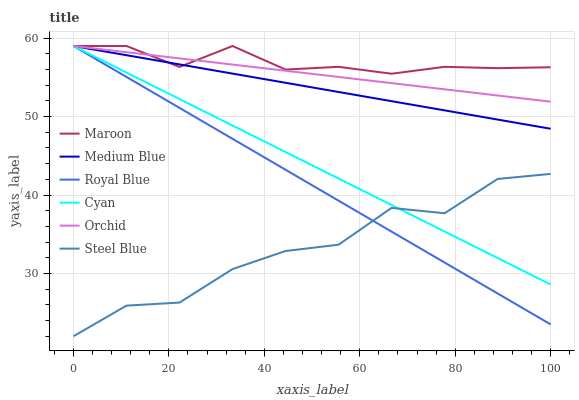Does Steel Blue have the minimum area under the curve?
Answer yes or no. Yes. Does Maroon have the maximum area under the curve?
Answer yes or no. Yes. Does Maroon have the minimum area under the curve?
Answer yes or no. No. Does Steel Blue have the maximum area under the curve?
Answer yes or no. No. Is Orchid the smoothest?
Answer yes or no. Yes. Is Steel Blue the roughest?
Answer yes or no. Yes. Is Maroon the smoothest?
Answer yes or no. No. Is Maroon the roughest?
Answer yes or no. No. Does Maroon have the lowest value?
Answer yes or no. No. Does Steel Blue have the highest value?
Answer yes or no. No. Is Steel Blue less than Medium Blue?
Answer yes or no. Yes. Is Orchid greater than Steel Blue?
Answer yes or no. Yes. Does Steel Blue intersect Medium Blue?
Answer yes or no. No. 